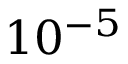<formula> <loc_0><loc_0><loc_500><loc_500>1 0 ^ { - 5 }</formula> 